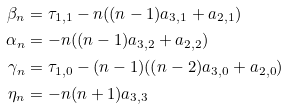<formula> <loc_0><loc_0><loc_500><loc_500>\beta _ { n } & = \tau _ { 1 , 1 } - n ( ( n - 1 ) a _ { 3 , 1 } + a _ { 2 , 1 } ) \\ \alpha _ { n } & = - n ( ( n - 1 ) a _ { 3 , 2 } + a _ { 2 , 2 } ) \\ \gamma _ { n } & = \tau _ { 1 , 0 } - ( n - 1 ) ( ( n - 2 ) a _ { 3 , 0 } + a _ { 2 , 0 } ) \\ \eta _ { n } & = - n ( n + 1 ) a _ { 3 , 3 }</formula> 